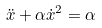<formula> <loc_0><loc_0><loc_500><loc_500>\ddot { x } + \alpha { \dot { x } } ^ { 2 } = \alpha</formula> 